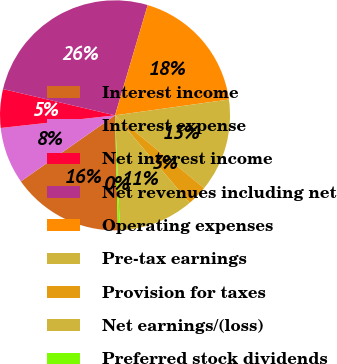Convert chart. <chart><loc_0><loc_0><loc_500><loc_500><pie_chart><fcel>Interest income<fcel>Interest expense<fcel>Net interest income<fcel>Net revenues including net<fcel>Operating expenses<fcel>Pre-tax earnings<fcel>Provision for taxes<fcel>Net earnings/(loss)<fcel>Preferred stock dividends<nl><fcel>15.66%<fcel>7.98%<fcel>5.42%<fcel>25.91%<fcel>18.22%<fcel>13.1%<fcel>2.86%<fcel>10.54%<fcel>0.3%<nl></chart> 